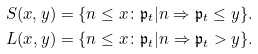<formula> <loc_0><loc_0><loc_500><loc_500>& S ( x , y ) = \{ n \leq x \colon \mathfrak { p } _ { t } | n \Rightarrow \mathfrak { p } _ { t } \leq y \} . \\ & L ( x , y ) = \{ n \leq x \colon \mathfrak { p } _ { t } | n \Rightarrow \mathfrak { p } _ { t } > y \} .</formula> 